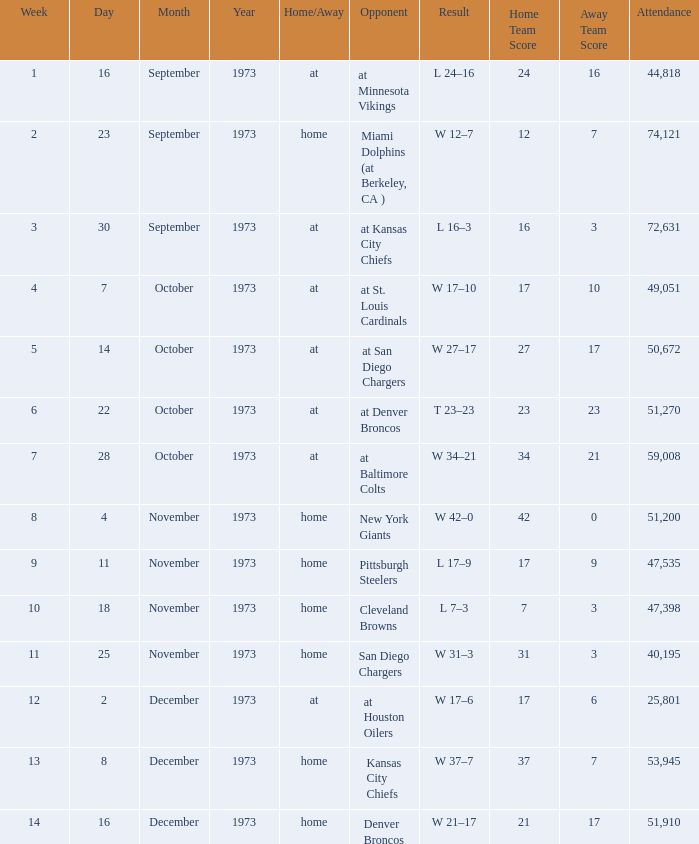What is the result later than week 13? W 21–17. 